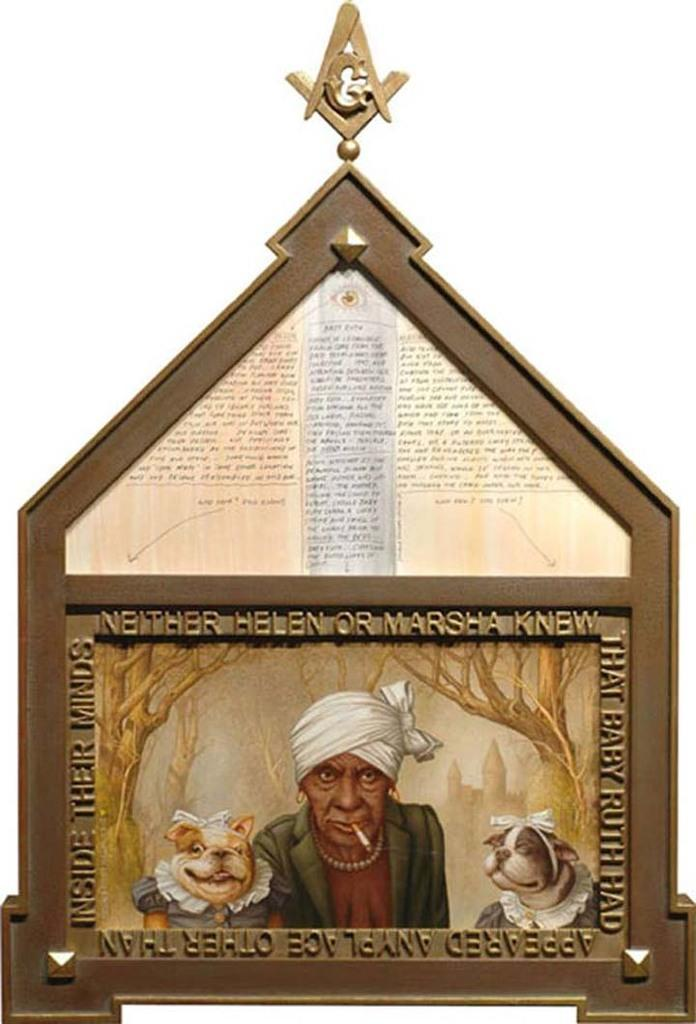What type of material is the frame in the image made of? The frame in the image is made of wood. What is displayed on the wooden frame? There is a photo and a paper on the wooden frame. Are there any words on the wooden frame? Yes, there are words on the wooden frame. What color is the background behind the wooden frame? The background behind the wooden frame is white. What type of disease is depicted in the photo on the wooden frame? There is no disease depicted in the photo on the wooden frame; it is not mentioned in the provided facts. 